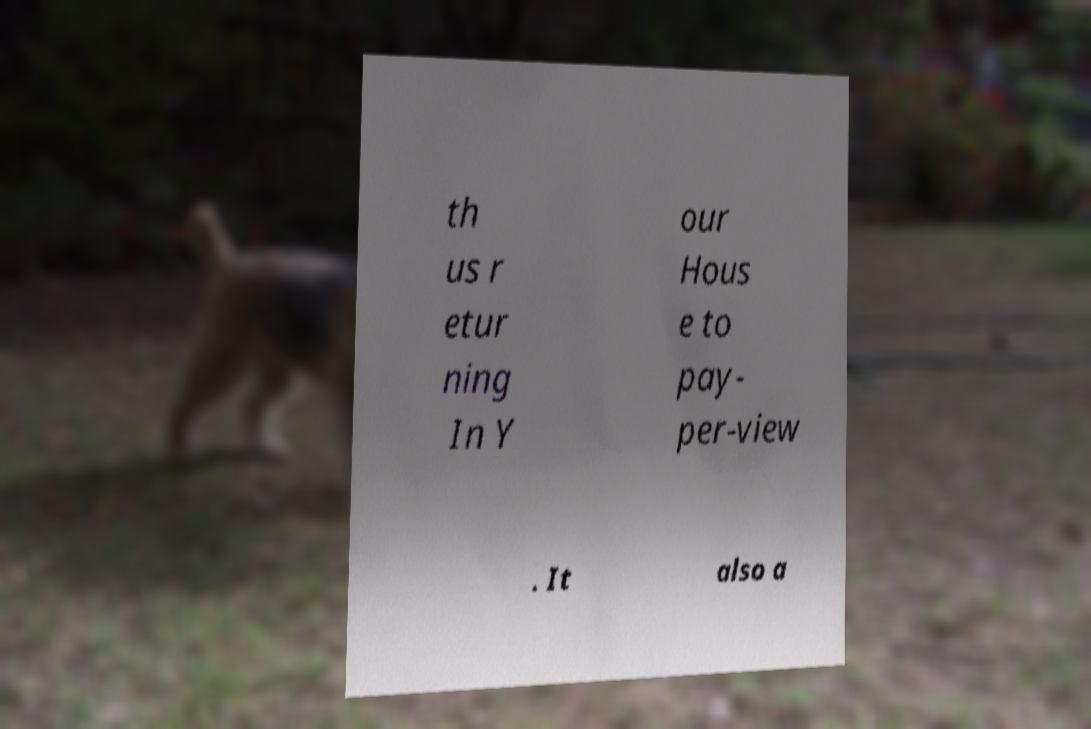Please read and relay the text visible in this image. What does it say? th us r etur ning In Y our Hous e to pay- per-view . It also a 